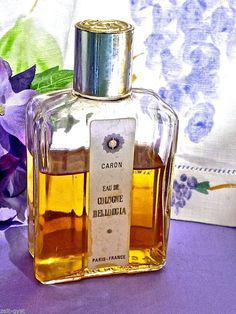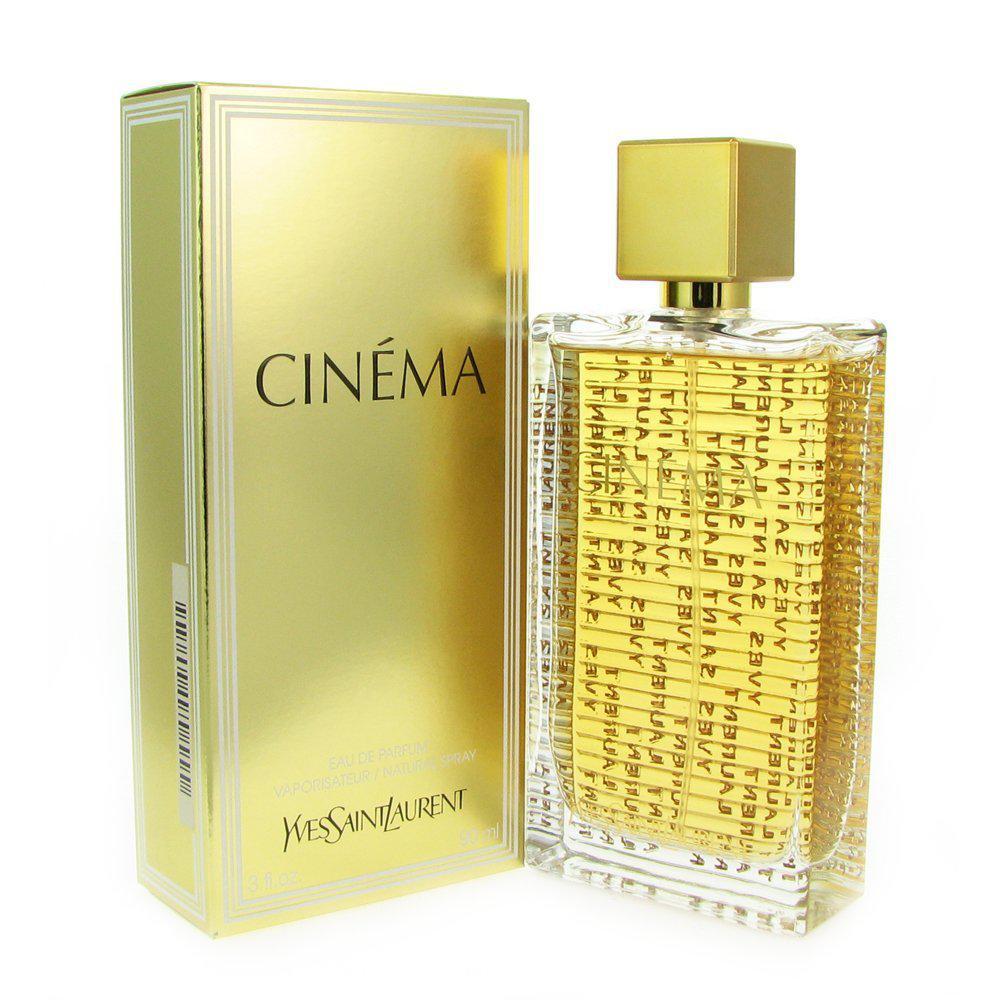The first image is the image on the left, the second image is the image on the right. Analyze the images presented: Is the assertion "There are at least five bottles of perfume." valid? Answer yes or no. No. The first image is the image on the left, the second image is the image on the right. Given the left and right images, does the statement "There are at least four bottles of perfume." hold true? Answer yes or no. No. 